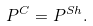<formula> <loc_0><loc_0><loc_500><loc_500>P ^ { C } = P ^ { S h } .</formula> 